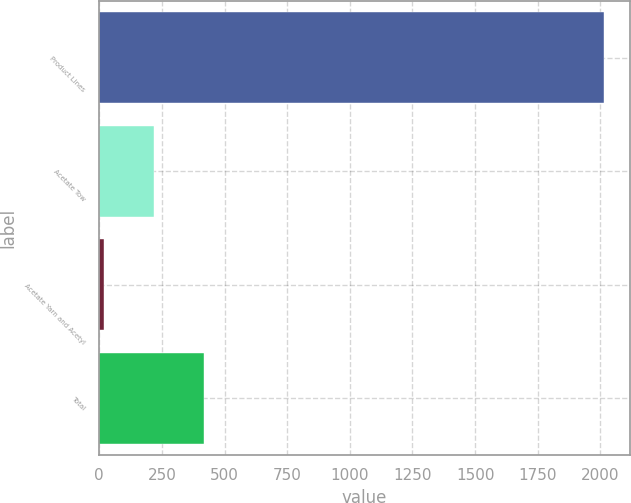Convert chart to OTSL. <chart><loc_0><loc_0><loc_500><loc_500><bar_chart><fcel>Product Lines<fcel>Acetate Tow<fcel>Acetate Yarn and Acetyl<fcel>Total<nl><fcel>2016<fcel>219.6<fcel>20<fcel>419.2<nl></chart> 